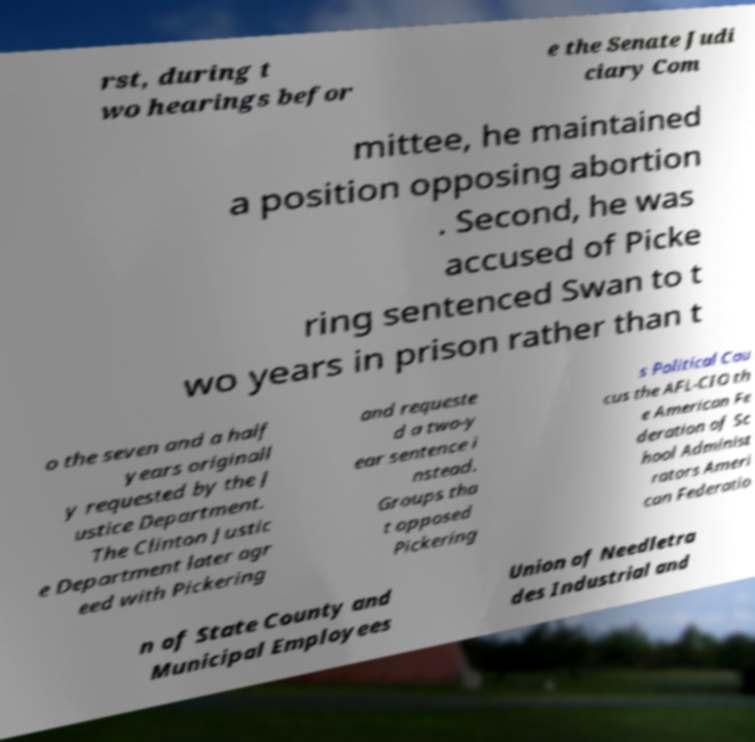Please read and relay the text visible in this image. What does it say? rst, during t wo hearings befor e the Senate Judi ciary Com mittee, he maintained a position opposing abortion . Second, he was accused of Picke ring sentenced Swan to t wo years in prison rather than t o the seven and a half years originall y requested by the J ustice Department. The Clinton Justic e Department later agr eed with Pickering and requeste d a two-y ear sentence i nstead. Groups tha t opposed Pickering s Political Cau cus the AFL-CIO th e American Fe deration of Sc hool Administ rators Ameri can Federatio n of State County and Municipal Employees Union of Needletra des Industrial and 